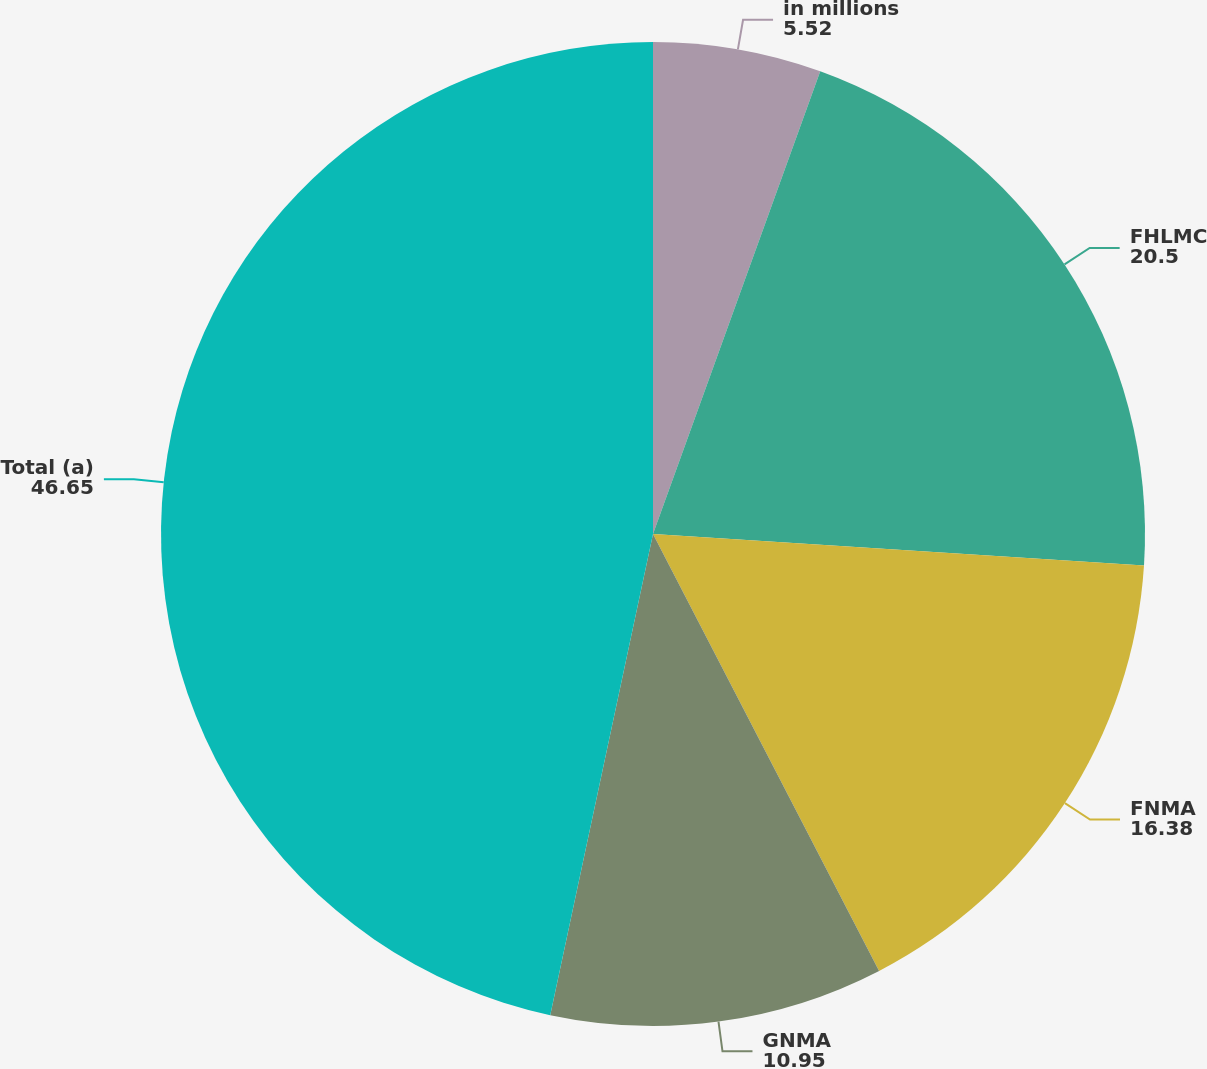Convert chart. <chart><loc_0><loc_0><loc_500><loc_500><pie_chart><fcel>in millions<fcel>FHLMC<fcel>FNMA<fcel>GNMA<fcel>Total (a)<nl><fcel>5.52%<fcel>20.5%<fcel>16.38%<fcel>10.95%<fcel>46.65%<nl></chart> 